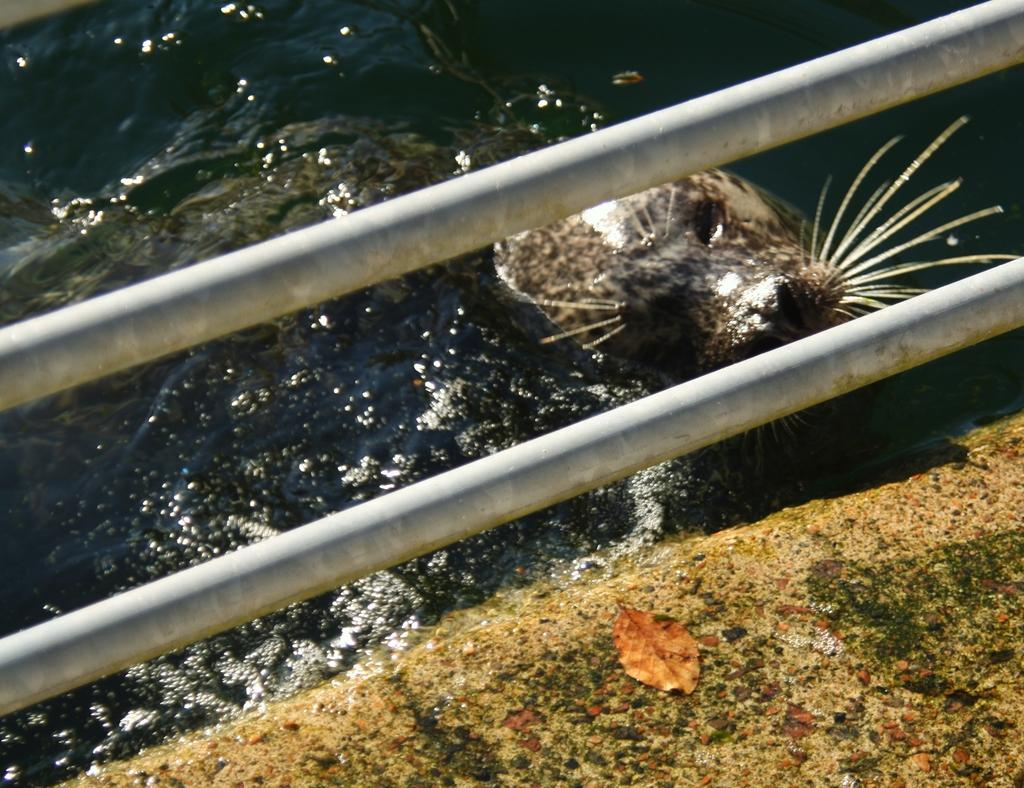What is in the water in the image? There is an animal in the water in the image. What objects can be seen besides the animal in the water? There are two metal rods in the image. What is on the ground in the image? There is a leaf on the ground in the image. What is the limit of the debt that the animal in the image has? There is no information about debt in the image, as it features an animal in the water and two metal rods. 